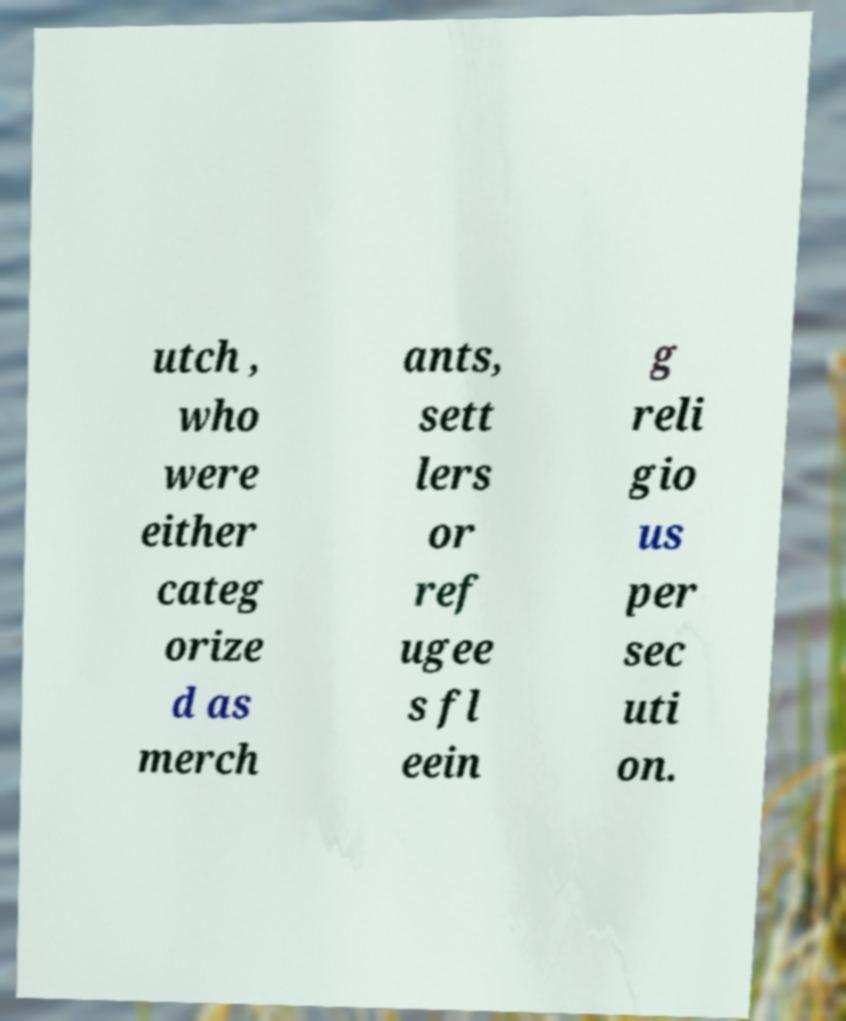What messages or text are displayed in this image? I need them in a readable, typed format. utch , who were either categ orize d as merch ants, sett lers or ref ugee s fl eein g reli gio us per sec uti on. 